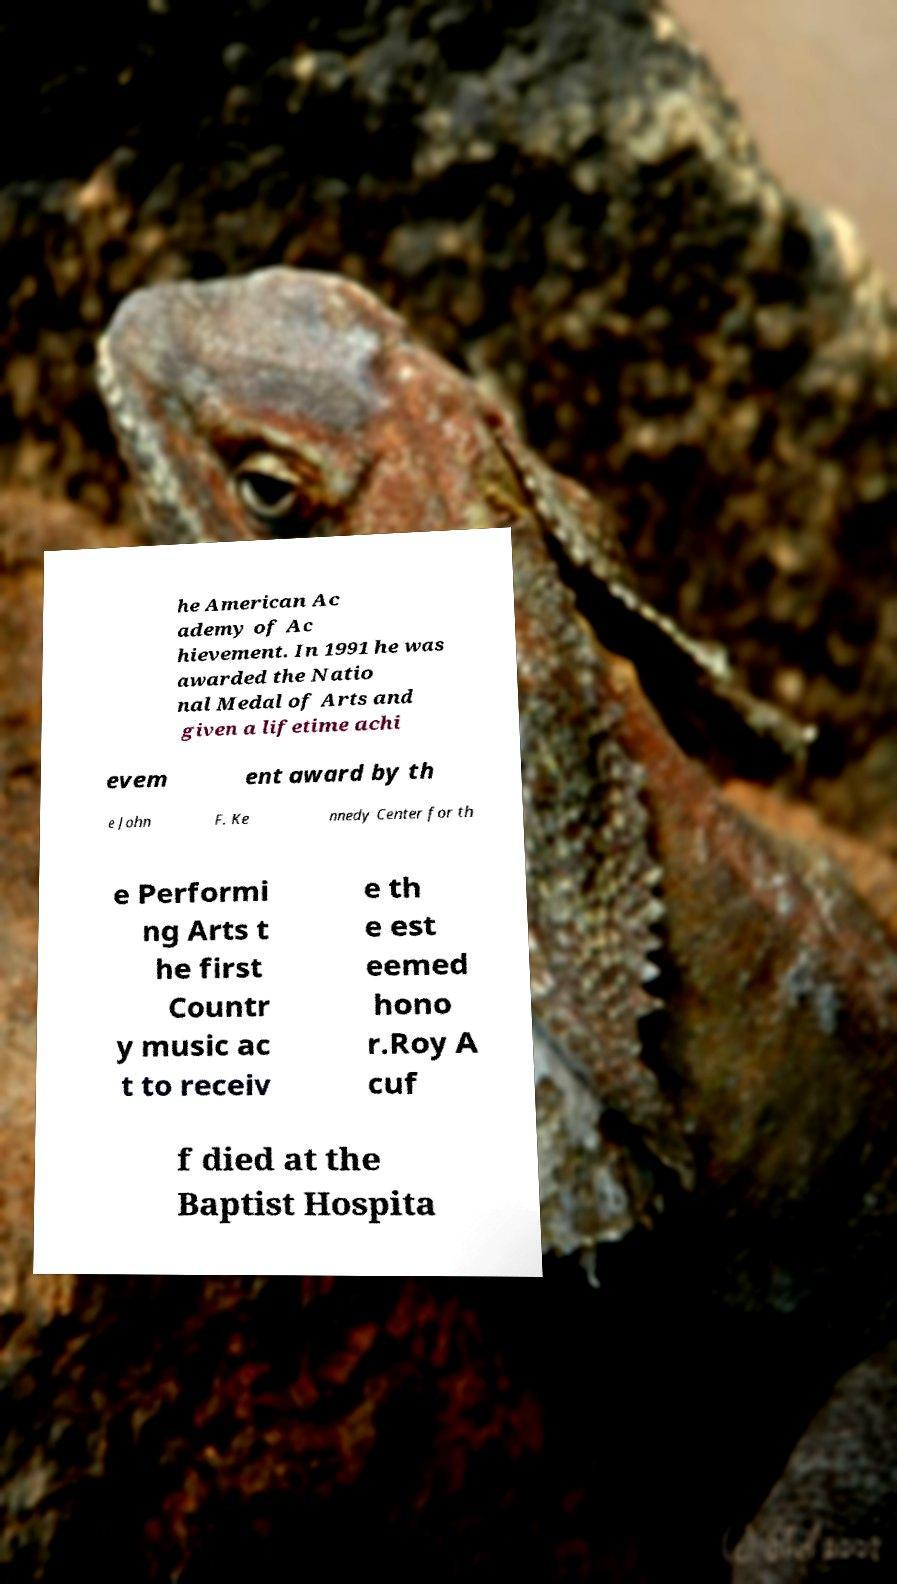Can you read and provide the text displayed in the image?This photo seems to have some interesting text. Can you extract and type it out for me? he American Ac ademy of Ac hievement. In 1991 he was awarded the Natio nal Medal of Arts and given a lifetime achi evem ent award by th e John F. Ke nnedy Center for th e Performi ng Arts t he first Countr y music ac t to receiv e th e est eemed hono r.Roy A cuf f died at the Baptist Hospita 